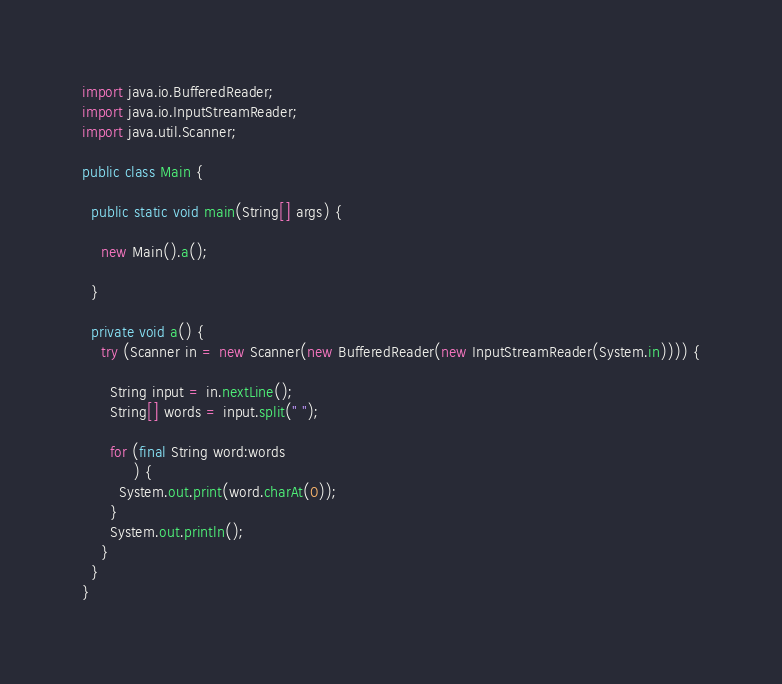Convert code to text. <code><loc_0><loc_0><loc_500><loc_500><_Java_>import java.io.BufferedReader;
import java.io.InputStreamReader;
import java.util.Scanner;

public class Main {

  public static void main(String[] args) {

    new Main().a();

  }

  private void a() {
    try (Scanner in = new Scanner(new BufferedReader(new InputStreamReader(System.in)))) {

      String input = in.nextLine();
      String[] words = input.split(" ");

      for (final String word:words
           ) {
        System.out.print(word.charAt(0));
      }
      System.out.println();
    }
  }
}
</code> 